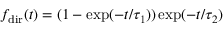Convert formula to latex. <formula><loc_0><loc_0><loc_500><loc_500>f _ { d i r } ( t ) = ( 1 - \exp ( - t / \tau _ { 1 } ) ) \exp ( - t / \tau _ { 2 } )</formula> 